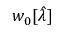<formula> <loc_0><loc_0><loc_500><loc_500>w _ { 0 } [ \hat { \lambda } ]</formula> 